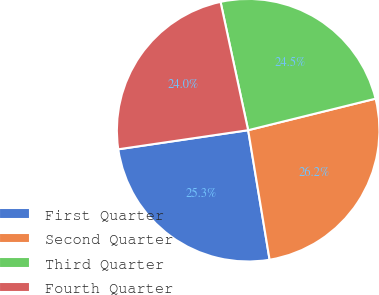Convert chart to OTSL. <chart><loc_0><loc_0><loc_500><loc_500><pie_chart><fcel>First Quarter<fcel>Second Quarter<fcel>Third Quarter<fcel>Fourth Quarter<nl><fcel>25.29%<fcel>26.25%<fcel>24.51%<fcel>23.95%<nl></chart> 